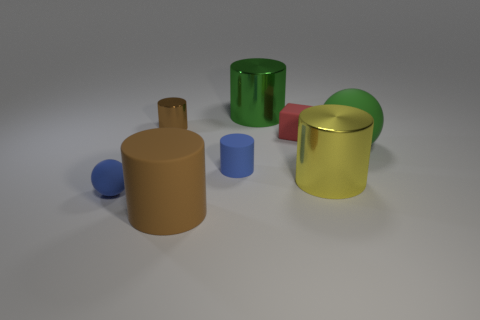What is the shape of the yellow shiny thing? The yellow shiny object in the image is a cylinder. Its reflective surface suggests it's likely made of a polished metal, giving it a lustrous appearance. 